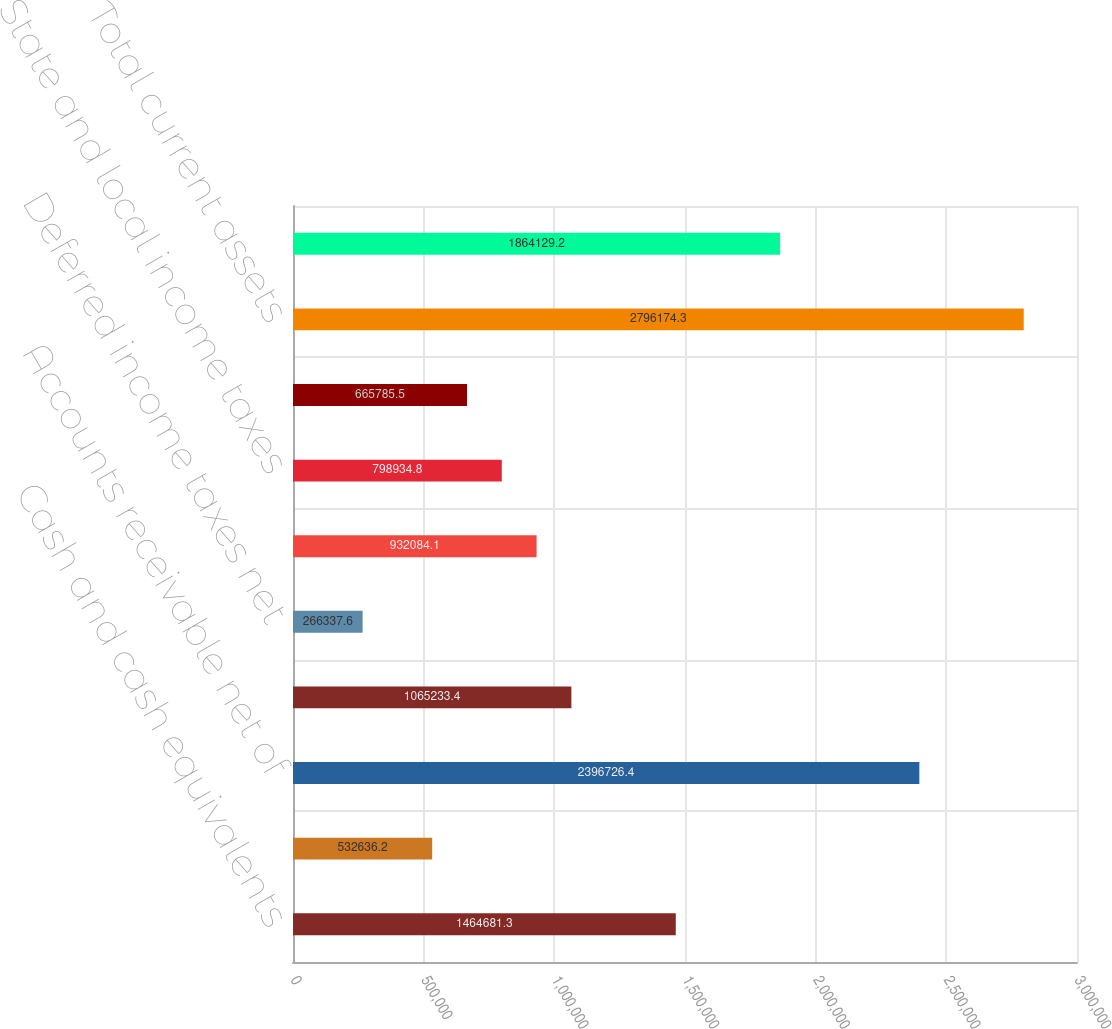Convert chart. <chart><loc_0><loc_0><loc_500><loc_500><bar_chart><fcel>Cash and cash equivalents<fcel>Available-for-sale securities<fcel>Accounts receivable net of<fcel>Prepaid expenses<fcel>Deferred income taxes net<fcel>Federal and foreign income<fcel>State and local income taxes<fcel>Other current assets<fcel>Total current assets<fcel>Fixed assets net<nl><fcel>1.46468e+06<fcel>532636<fcel>2.39673e+06<fcel>1.06523e+06<fcel>266338<fcel>932084<fcel>798935<fcel>665786<fcel>2.79617e+06<fcel>1.86413e+06<nl></chart> 